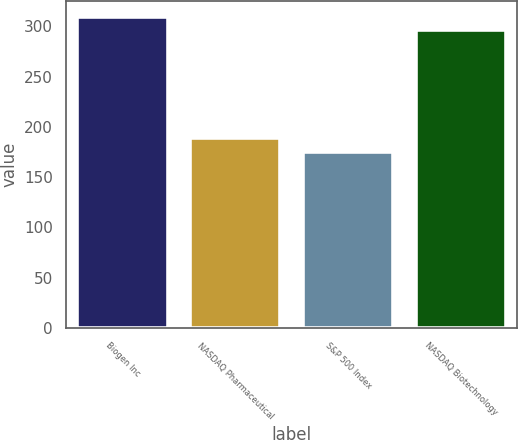Convert chart. <chart><loc_0><loc_0><loc_500><loc_500><bar_chart><fcel>Biogen Inc<fcel>NASDAQ Pharmaceutical<fcel>S&P 500 Index<fcel>NASDAQ Biotechnology<nl><fcel>309.57<fcel>188.95<fcel>174.6<fcel>296.19<nl></chart> 